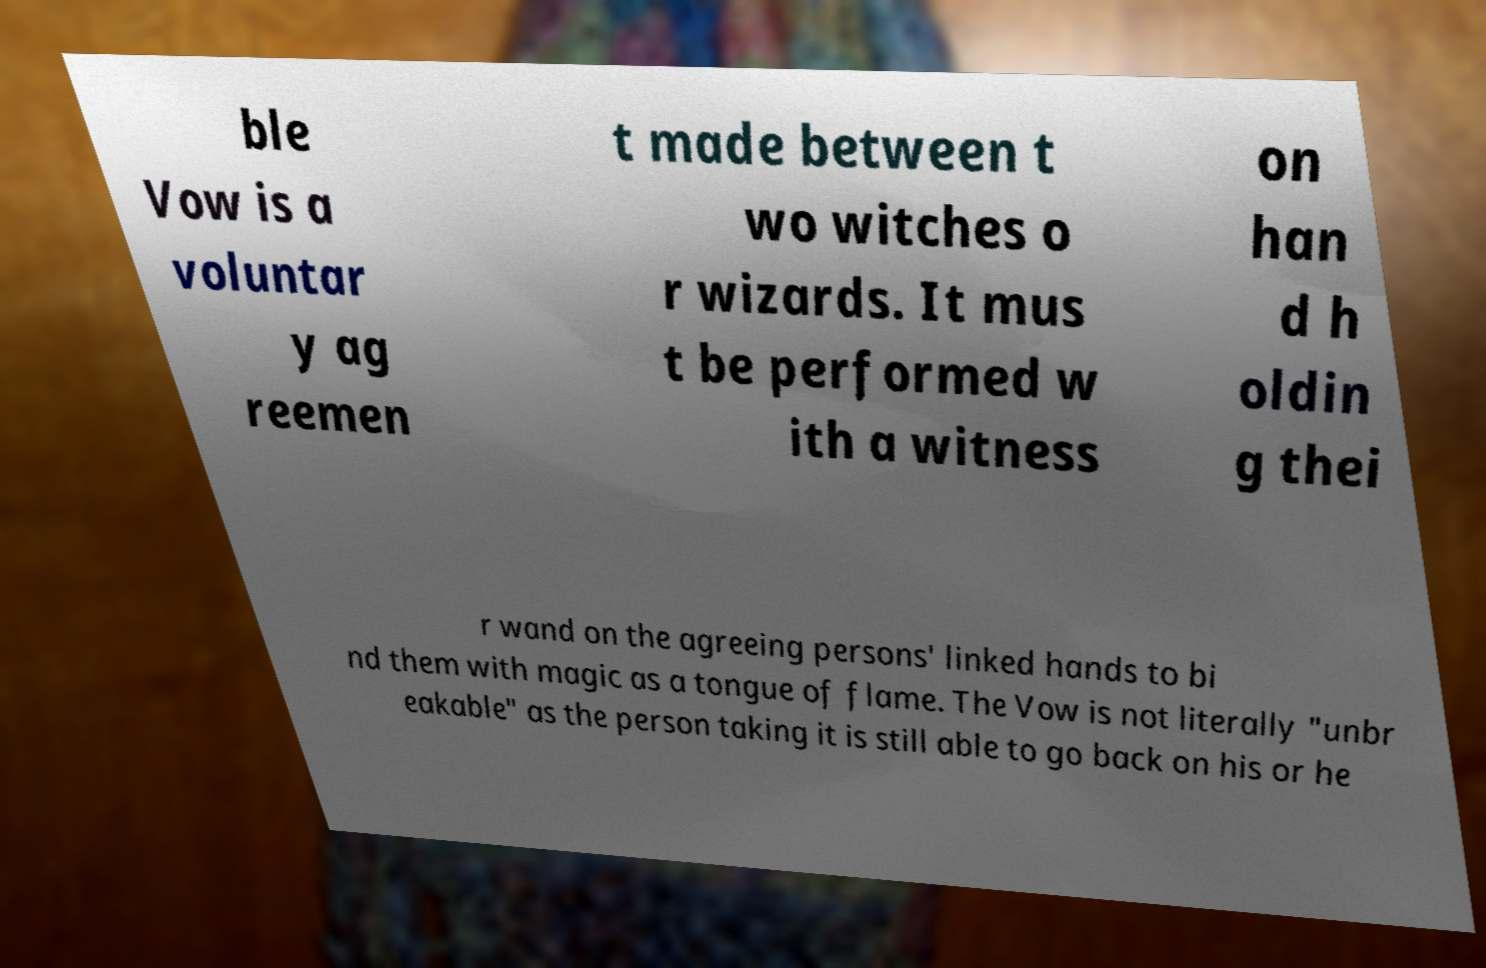Please read and relay the text visible in this image. What does it say? ble Vow is a voluntar y ag reemen t made between t wo witches o r wizards. It mus t be performed w ith a witness on han d h oldin g thei r wand on the agreeing persons' linked hands to bi nd them with magic as a tongue of flame. The Vow is not literally "unbr eakable" as the person taking it is still able to go back on his or he 